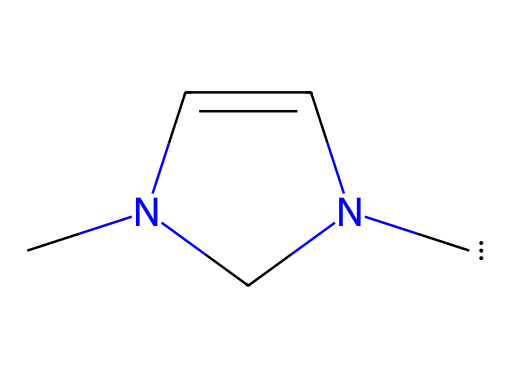What type of chemical is represented by the SMILES? The presence of the carbene center is indicated by the carbon atom bonded to two other groups without having a complete octet. This structure classifies it as a carbene.
Answer: carbene How many nitrogen atoms are in the SMILES representation? Analyzing the chemical structure, there are two nitrogen atoms evident in the ring, connected to carbon atoms.
Answer: two What is the cyclic structure present in the SMILES? The SMILES shows a five-membered ring involving three carbon atoms and two nitrogen atoms. This is confirmed by the 'N' and 'C' atom placements in the cycle.
Answer: five-membered ring Is the nitrogen in this carbene likely basic or acidic? Given the nitrogen's position in the five-membered ring and the overall structure, it can act as a Lewis base due to the availability of lone pair electrons.
Answer: basic What type of reaction can this carbene likely participate in? Carbenes are known to participate in various reactions, including insertion reactions. This specific persistent carbene type suggests it can efficiently insert into C-H bonds or be involved in cyclopropanation.
Answer: insertion reactions What is the hybridization state of the carbene carbon? The carbene carbon is bonded to two other substituents and is likely sp² hybridized due to having a planar arrangement and one empty p-orbital available for stabilization.
Answer: sp² What geometry does the nitrogen atom have in the ring? The nitrogen atoms in the five-membered ring typically adopt a trigonal planar geometry due to their hybridization and connectivity, which allows electron pair repulsion to be minimized.
Answer: trigonal planar 